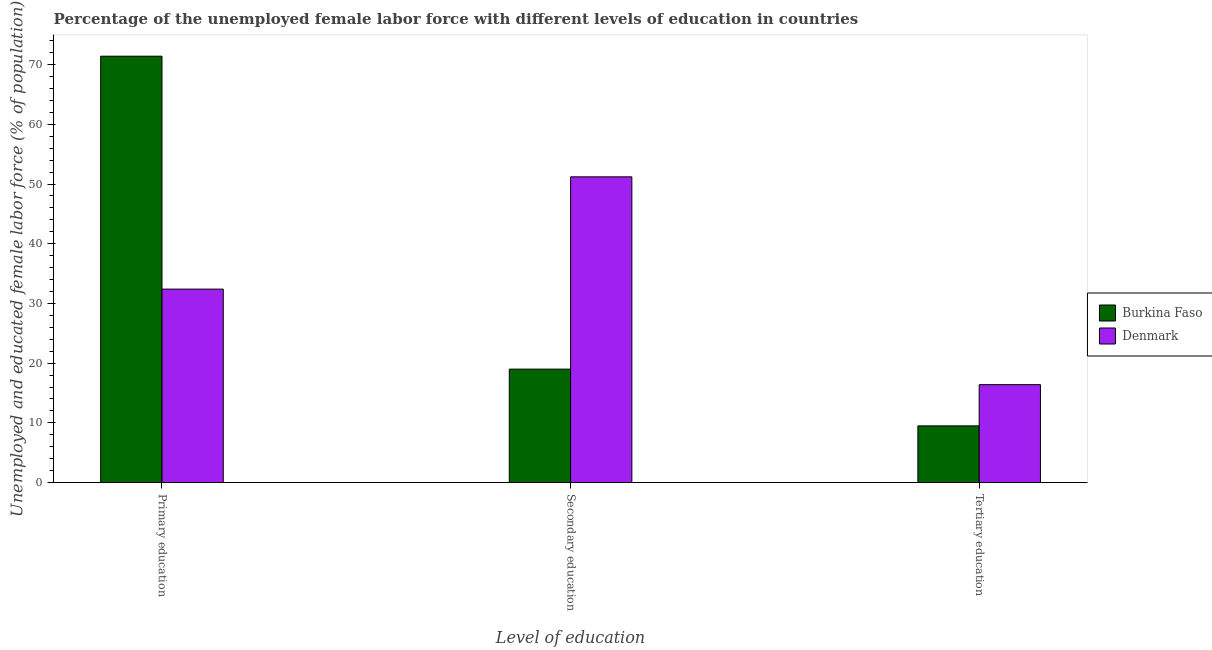How many different coloured bars are there?
Provide a short and direct response. 2. Are the number of bars per tick equal to the number of legend labels?
Offer a terse response. Yes. How many bars are there on the 1st tick from the left?
Offer a very short reply. 2. How many bars are there on the 1st tick from the right?
Provide a short and direct response. 2. What is the label of the 2nd group of bars from the left?
Your answer should be very brief. Secondary education. What is the percentage of female labor force who received tertiary education in Burkina Faso?
Offer a terse response. 9.5. Across all countries, what is the maximum percentage of female labor force who received secondary education?
Your response must be concise. 51.2. In which country was the percentage of female labor force who received tertiary education maximum?
Offer a terse response. Denmark. In which country was the percentage of female labor force who received secondary education minimum?
Your response must be concise. Burkina Faso. What is the total percentage of female labor force who received tertiary education in the graph?
Provide a succinct answer. 25.9. What is the difference between the percentage of female labor force who received tertiary education in Burkina Faso and that in Denmark?
Offer a terse response. -6.9. What is the difference between the percentage of female labor force who received tertiary education in Denmark and the percentage of female labor force who received primary education in Burkina Faso?
Your answer should be compact. -55. What is the average percentage of female labor force who received primary education per country?
Make the answer very short. 51.9. What is the difference between the percentage of female labor force who received primary education and percentage of female labor force who received tertiary education in Denmark?
Offer a very short reply. 16. In how many countries, is the percentage of female labor force who received tertiary education greater than 48 %?
Keep it short and to the point. 0. What is the ratio of the percentage of female labor force who received primary education in Denmark to that in Burkina Faso?
Offer a very short reply. 0.45. Is the percentage of female labor force who received tertiary education in Burkina Faso less than that in Denmark?
Your response must be concise. Yes. Is the difference between the percentage of female labor force who received tertiary education in Denmark and Burkina Faso greater than the difference between the percentage of female labor force who received primary education in Denmark and Burkina Faso?
Ensure brevity in your answer.  Yes. What is the difference between the highest and the second highest percentage of female labor force who received tertiary education?
Ensure brevity in your answer.  6.9. What is the difference between the highest and the lowest percentage of female labor force who received secondary education?
Your response must be concise. 32.2. In how many countries, is the percentage of female labor force who received tertiary education greater than the average percentage of female labor force who received tertiary education taken over all countries?
Your answer should be very brief. 1. Is the sum of the percentage of female labor force who received primary education in Burkina Faso and Denmark greater than the maximum percentage of female labor force who received tertiary education across all countries?
Your answer should be compact. Yes. What does the 1st bar from the left in Secondary education represents?
Give a very brief answer. Burkina Faso. What does the 1st bar from the right in Primary education represents?
Your answer should be compact. Denmark. How many countries are there in the graph?
Ensure brevity in your answer.  2. Does the graph contain any zero values?
Your answer should be very brief. No. Does the graph contain grids?
Provide a succinct answer. No. How are the legend labels stacked?
Provide a succinct answer. Vertical. What is the title of the graph?
Provide a succinct answer. Percentage of the unemployed female labor force with different levels of education in countries. Does "Poland" appear as one of the legend labels in the graph?
Provide a succinct answer. No. What is the label or title of the X-axis?
Your answer should be very brief. Level of education. What is the label or title of the Y-axis?
Your answer should be very brief. Unemployed and educated female labor force (% of population). What is the Unemployed and educated female labor force (% of population) of Burkina Faso in Primary education?
Offer a very short reply. 71.4. What is the Unemployed and educated female labor force (% of population) of Denmark in Primary education?
Offer a very short reply. 32.4. What is the Unemployed and educated female labor force (% of population) in Burkina Faso in Secondary education?
Your response must be concise. 19. What is the Unemployed and educated female labor force (% of population) of Denmark in Secondary education?
Your answer should be compact. 51.2. What is the Unemployed and educated female labor force (% of population) in Burkina Faso in Tertiary education?
Your answer should be compact. 9.5. What is the Unemployed and educated female labor force (% of population) of Denmark in Tertiary education?
Give a very brief answer. 16.4. Across all Level of education, what is the maximum Unemployed and educated female labor force (% of population) of Burkina Faso?
Provide a short and direct response. 71.4. Across all Level of education, what is the maximum Unemployed and educated female labor force (% of population) of Denmark?
Keep it short and to the point. 51.2. Across all Level of education, what is the minimum Unemployed and educated female labor force (% of population) in Denmark?
Your answer should be compact. 16.4. What is the total Unemployed and educated female labor force (% of population) in Burkina Faso in the graph?
Give a very brief answer. 99.9. What is the total Unemployed and educated female labor force (% of population) in Denmark in the graph?
Offer a terse response. 100. What is the difference between the Unemployed and educated female labor force (% of population) in Burkina Faso in Primary education and that in Secondary education?
Offer a very short reply. 52.4. What is the difference between the Unemployed and educated female labor force (% of population) of Denmark in Primary education and that in Secondary education?
Ensure brevity in your answer.  -18.8. What is the difference between the Unemployed and educated female labor force (% of population) of Burkina Faso in Primary education and that in Tertiary education?
Your answer should be compact. 61.9. What is the difference between the Unemployed and educated female labor force (% of population) in Denmark in Secondary education and that in Tertiary education?
Offer a terse response. 34.8. What is the difference between the Unemployed and educated female labor force (% of population) in Burkina Faso in Primary education and the Unemployed and educated female labor force (% of population) in Denmark in Secondary education?
Ensure brevity in your answer.  20.2. What is the difference between the Unemployed and educated female labor force (% of population) in Burkina Faso in Primary education and the Unemployed and educated female labor force (% of population) in Denmark in Tertiary education?
Your answer should be compact. 55. What is the difference between the Unemployed and educated female labor force (% of population) of Burkina Faso in Secondary education and the Unemployed and educated female labor force (% of population) of Denmark in Tertiary education?
Offer a terse response. 2.6. What is the average Unemployed and educated female labor force (% of population) in Burkina Faso per Level of education?
Your answer should be compact. 33.3. What is the average Unemployed and educated female labor force (% of population) of Denmark per Level of education?
Offer a very short reply. 33.33. What is the difference between the Unemployed and educated female labor force (% of population) of Burkina Faso and Unemployed and educated female labor force (% of population) of Denmark in Primary education?
Make the answer very short. 39. What is the difference between the Unemployed and educated female labor force (% of population) in Burkina Faso and Unemployed and educated female labor force (% of population) in Denmark in Secondary education?
Offer a terse response. -32.2. What is the ratio of the Unemployed and educated female labor force (% of population) of Burkina Faso in Primary education to that in Secondary education?
Make the answer very short. 3.76. What is the ratio of the Unemployed and educated female labor force (% of population) of Denmark in Primary education to that in Secondary education?
Ensure brevity in your answer.  0.63. What is the ratio of the Unemployed and educated female labor force (% of population) of Burkina Faso in Primary education to that in Tertiary education?
Offer a very short reply. 7.52. What is the ratio of the Unemployed and educated female labor force (% of population) in Denmark in Primary education to that in Tertiary education?
Provide a succinct answer. 1.98. What is the ratio of the Unemployed and educated female labor force (% of population) of Burkina Faso in Secondary education to that in Tertiary education?
Ensure brevity in your answer.  2. What is the ratio of the Unemployed and educated female labor force (% of population) in Denmark in Secondary education to that in Tertiary education?
Make the answer very short. 3.12. What is the difference between the highest and the second highest Unemployed and educated female labor force (% of population) in Burkina Faso?
Offer a terse response. 52.4. What is the difference between the highest and the second highest Unemployed and educated female labor force (% of population) of Denmark?
Keep it short and to the point. 18.8. What is the difference between the highest and the lowest Unemployed and educated female labor force (% of population) in Burkina Faso?
Your answer should be very brief. 61.9. What is the difference between the highest and the lowest Unemployed and educated female labor force (% of population) of Denmark?
Offer a terse response. 34.8. 